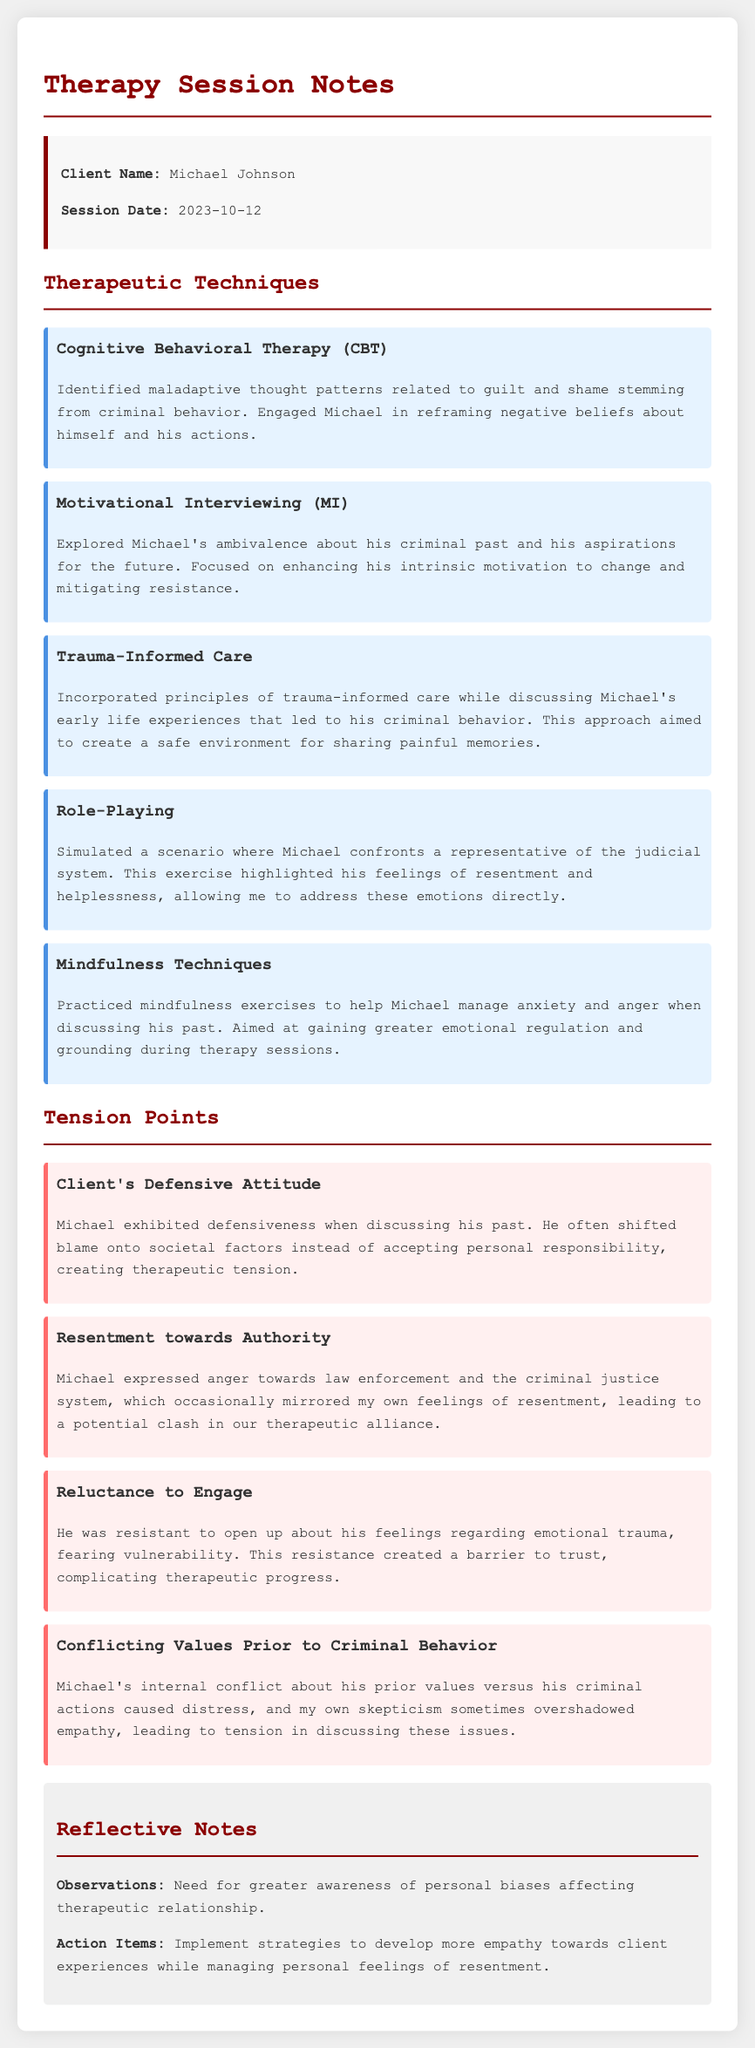What is the client's name? The client's name is provided in the session info section of the document.
Answer: Michael Johnson What therapeutic technique involves reframing negative beliefs? This technique is described under the therapeutic techniques section and focuses on combating guilt and shame.
Answer: Cognitive Behavioral Therapy (CBT) What date was the therapy session conducted? The session date is specified in the session info section of the document.
Answer: 2023-10-12 Which technique focuses on emotional regulation? The technique that aims to help manage anxiety and anger during discussions is mentioned in the therapeutic techniques section.
Answer: Mindfulness Techniques What tension point involves Michael's view of the criminal justice system? This tension point is noted in the tension points section related to Michael's feelings of anger.
Answer: Resentment towards Authority How did Michael demonstrate defensiveness in the session? The document describes how he shifted blame instead of accepting responsibility, impacting the therapeutic process.
Answer: Shifted blame onto societal factors What is an action item noted for the therapist? One action item focuses on addressing personal feelings that might impact the therapy.
Answer: Develop more empathy towards client experiences Which therapeutic technique is used to explore ambivalence about the criminal past? This technique is mentioned in the therapeutic techniques section, focusing on enhancing motivation for change.
Answer: Motivational Interviewing (MI) What is a key observation made in the reflective notes? The reflective notes state an important observation about biases affecting therapy.
Answer: Awareness of personal biases 